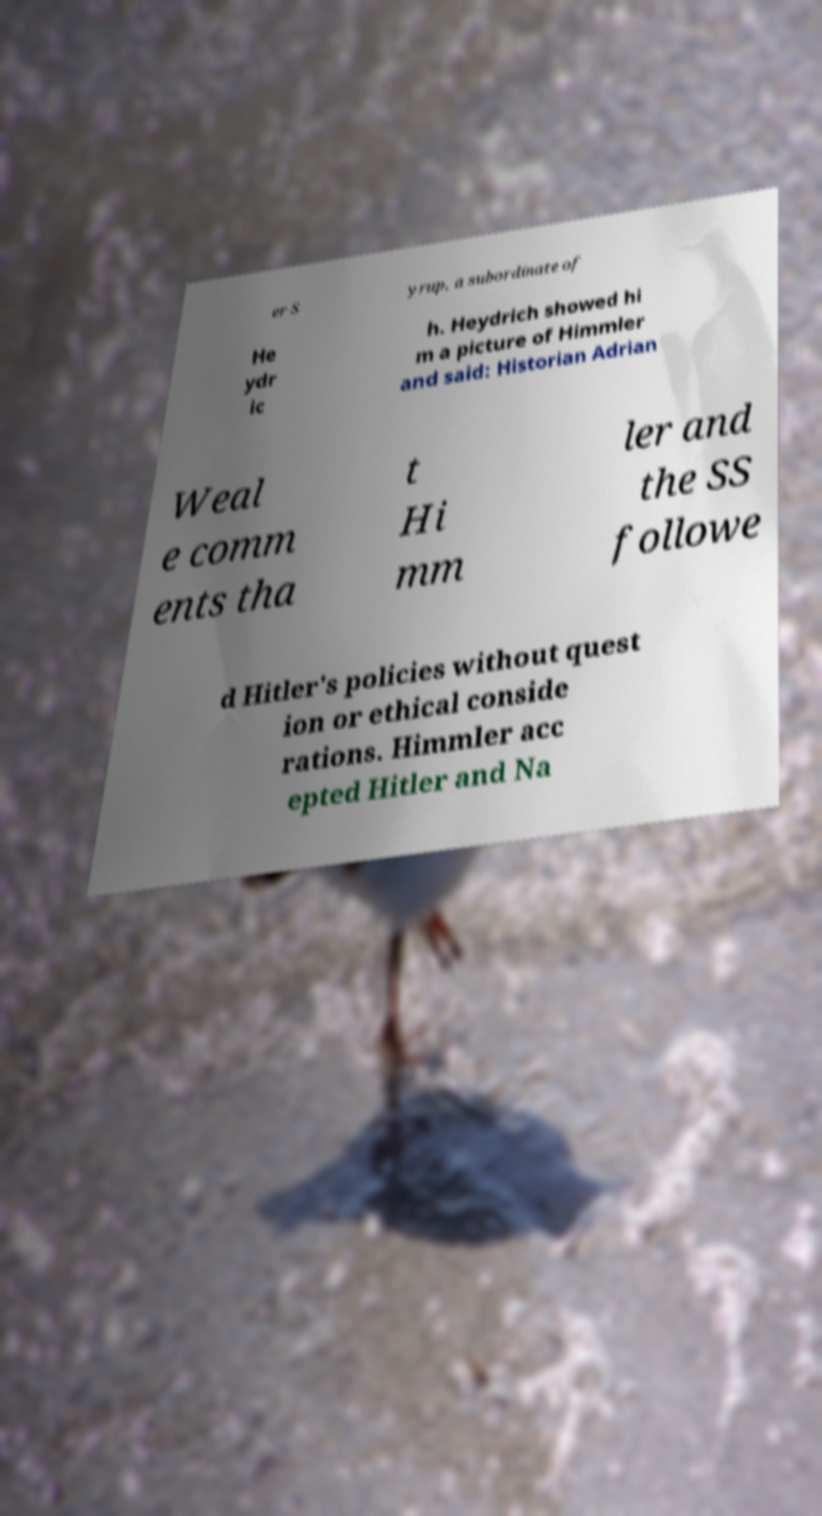I need the written content from this picture converted into text. Can you do that? er S yrup, a subordinate of He ydr ic h. Heydrich showed hi m a picture of Himmler and said: Historian Adrian Weal e comm ents tha t Hi mm ler and the SS followe d Hitler's policies without quest ion or ethical conside rations. Himmler acc epted Hitler and Na 